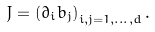Convert formula to latex. <formula><loc_0><loc_0><loc_500><loc_500>J = \left ( \partial _ { i } b _ { j } \right ) _ { i , j = 1 , \dots , d } .</formula> 